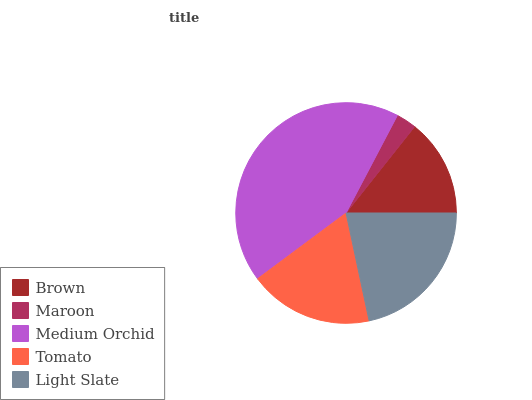Is Maroon the minimum?
Answer yes or no. Yes. Is Medium Orchid the maximum?
Answer yes or no. Yes. Is Medium Orchid the minimum?
Answer yes or no. No. Is Maroon the maximum?
Answer yes or no. No. Is Medium Orchid greater than Maroon?
Answer yes or no. Yes. Is Maroon less than Medium Orchid?
Answer yes or no. Yes. Is Maroon greater than Medium Orchid?
Answer yes or no. No. Is Medium Orchid less than Maroon?
Answer yes or no. No. Is Tomato the high median?
Answer yes or no. Yes. Is Tomato the low median?
Answer yes or no. Yes. Is Maroon the high median?
Answer yes or no. No. Is Medium Orchid the low median?
Answer yes or no. No. 